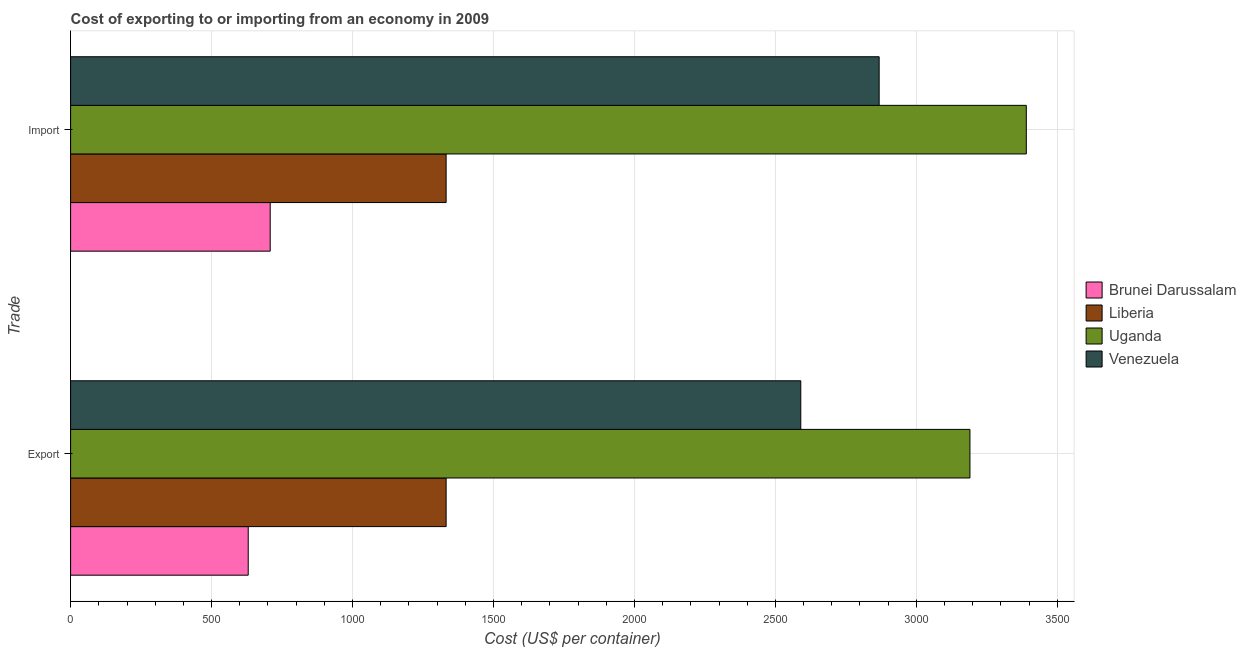How many different coloured bars are there?
Your answer should be compact. 4. How many bars are there on the 1st tick from the bottom?
Offer a very short reply. 4. What is the label of the 1st group of bars from the top?
Offer a very short reply. Import. What is the export cost in Brunei Darussalam?
Your response must be concise. 630. Across all countries, what is the maximum import cost?
Give a very brief answer. 3390. Across all countries, what is the minimum import cost?
Provide a succinct answer. 708. In which country was the export cost maximum?
Give a very brief answer. Uganda. In which country was the import cost minimum?
Provide a short and direct response. Brunei Darussalam. What is the total import cost in the graph?
Provide a succinct answer. 8298. What is the difference between the import cost in Venezuela and the export cost in Liberia?
Offer a terse response. 1536. What is the average import cost per country?
Offer a very short reply. 2074.5. What is the difference between the export cost and import cost in Brunei Darussalam?
Your answer should be compact. -78. In how many countries, is the import cost greater than 1100 US$?
Keep it short and to the point. 3. What is the ratio of the export cost in Brunei Darussalam to that in Venezuela?
Your answer should be very brief. 0.24. What does the 4th bar from the top in Import represents?
Your answer should be compact. Brunei Darussalam. What does the 1st bar from the bottom in Export represents?
Your response must be concise. Brunei Darussalam. How many countries are there in the graph?
Offer a terse response. 4. What is the difference between two consecutive major ticks on the X-axis?
Your answer should be very brief. 500. Are the values on the major ticks of X-axis written in scientific E-notation?
Make the answer very short. No. Does the graph contain any zero values?
Provide a succinct answer. No. Does the graph contain grids?
Your answer should be very brief. Yes. Where does the legend appear in the graph?
Provide a short and direct response. Center right. How many legend labels are there?
Ensure brevity in your answer.  4. What is the title of the graph?
Provide a succinct answer. Cost of exporting to or importing from an economy in 2009. What is the label or title of the X-axis?
Keep it short and to the point. Cost (US$ per container). What is the label or title of the Y-axis?
Your answer should be compact. Trade. What is the Cost (US$ per container) of Brunei Darussalam in Export?
Offer a terse response. 630. What is the Cost (US$ per container) in Liberia in Export?
Ensure brevity in your answer.  1332. What is the Cost (US$ per container) in Uganda in Export?
Make the answer very short. 3190. What is the Cost (US$ per container) in Venezuela in Export?
Your answer should be compact. 2590. What is the Cost (US$ per container) of Brunei Darussalam in Import?
Your answer should be compact. 708. What is the Cost (US$ per container) in Liberia in Import?
Your answer should be compact. 1332. What is the Cost (US$ per container) of Uganda in Import?
Your answer should be compact. 3390. What is the Cost (US$ per container) of Venezuela in Import?
Offer a very short reply. 2868. Across all Trade, what is the maximum Cost (US$ per container) of Brunei Darussalam?
Offer a very short reply. 708. Across all Trade, what is the maximum Cost (US$ per container) in Liberia?
Provide a succinct answer. 1332. Across all Trade, what is the maximum Cost (US$ per container) of Uganda?
Make the answer very short. 3390. Across all Trade, what is the maximum Cost (US$ per container) in Venezuela?
Provide a succinct answer. 2868. Across all Trade, what is the minimum Cost (US$ per container) in Brunei Darussalam?
Provide a succinct answer. 630. Across all Trade, what is the minimum Cost (US$ per container) of Liberia?
Make the answer very short. 1332. Across all Trade, what is the minimum Cost (US$ per container) of Uganda?
Provide a succinct answer. 3190. Across all Trade, what is the minimum Cost (US$ per container) of Venezuela?
Make the answer very short. 2590. What is the total Cost (US$ per container) in Brunei Darussalam in the graph?
Ensure brevity in your answer.  1338. What is the total Cost (US$ per container) in Liberia in the graph?
Offer a terse response. 2664. What is the total Cost (US$ per container) in Uganda in the graph?
Provide a succinct answer. 6580. What is the total Cost (US$ per container) in Venezuela in the graph?
Offer a very short reply. 5458. What is the difference between the Cost (US$ per container) in Brunei Darussalam in Export and that in Import?
Offer a terse response. -78. What is the difference between the Cost (US$ per container) in Uganda in Export and that in Import?
Make the answer very short. -200. What is the difference between the Cost (US$ per container) of Venezuela in Export and that in Import?
Provide a succinct answer. -278. What is the difference between the Cost (US$ per container) of Brunei Darussalam in Export and the Cost (US$ per container) of Liberia in Import?
Ensure brevity in your answer.  -702. What is the difference between the Cost (US$ per container) of Brunei Darussalam in Export and the Cost (US$ per container) of Uganda in Import?
Ensure brevity in your answer.  -2760. What is the difference between the Cost (US$ per container) in Brunei Darussalam in Export and the Cost (US$ per container) in Venezuela in Import?
Provide a succinct answer. -2238. What is the difference between the Cost (US$ per container) in Liberia in Export and the Cost (US$ per container) in Uganda in Import?
Provide a succinct answer. -2058. What is the difference between the Cost (US$ per container) of Liberia in Export and the Cost (US$ per container) of Venezuela in Import?
Your response must be concise. -1536. What is the difference between the Cost (US$ per container) of Uganda in Export and the Cost (US$ per container) of Venezuela in Import?
Provide a short and direct response. 322. What is the average Cost (US$ per container) of Brunei Darussalam per Trade?
Keep it short and to the point. 669. What is the average Cost (US$ per container) of Liberia per Trade?
Offer a very short reply. 1332. What is the average Cost (US$ per container) in Uganda per Trade?
Provide a short and direct response. 3290. What is the average Cost (US$ per container) in Venezuela per Trade?
Keep it short and to the point. 2729. What is the difference between the Cost (US$ per container) in Brunei Darussalam and Cost (US$ per container) in Liberia in Export?
Ensure brevity in your answer.  -702. What is the difference between the Cost (US$ per container) of Brunei Darussalam and Cost (US$ per container) of Uganda in Export?
Your response must be concise. -2560. What is the difference between the Cost (US$ per container) in Brunei Darussalam and Cost (US$ per container) in Venezuela in Export?
Your response must be concise. -1960. What is the difference between the Cost (US$ per container) of Liberia and Cost (US$ per container) of Uganda in Export?
Give a very brief answer. -1858. What is the difference between the Cost (US$ per container) of Liberia and Cost (US$ per container) of Venezuela in Export?
Provide a succinct answer. -1258. What is the difference between the Cost (US$ per container) in Uganda and Cost (US$ per container) in Venezuela in Export?
Keep it short and to the point. 600. What is the difference between the Cost (US$ per container) in Brunei Darussalam and Cost (US$ per container) in Liberia in Import?
Provide a short and direct response. -624. What is the difference between the Cost (US$ per container) of Brunei Darussalam and Cost (US$ per container) of Uganda in Import?
Your answer should be compact. -2682. What is the difference between the Cost (US$ per container) in Brunei Darussalam and Cost (US$ per container) in Venezuela in Import?
Make the answer very short. -2160. What is the difference between the Cost (US$ per container) in Liberia and Cost (US$ per container) in Uganda in Import?
Your answer should be very brief. -2058. What is the difference between the Cost (US$ per container) of Liberia and Cost (US$ per container) of Venezuela in Import?
Offer a terse response. -1536. What is the difference between the Cost (US$ per container) in Uganda and Cost (US$ per container) in Venezuela in Import?
Keep it short and to the point. 522. What is the ratio of the Cost (US$ per container) in Brunei Darussalam in Export to that in Import?
Your answer should be compact. 0.89. What is the ratio of the Cost (US$ per container) in Uganda in Export to that in Import?
Your answer should be very brief. 0.94. What is the ratio of the Cost (US$ per container) of Venezuela in Export to that in Import?
Offer a very short reply. 0.9. What is the difference between the highest and the second highest Cost (US$ per container) of Brunei Darussalam?
Ensure brevity in your answer.  78. What is the difference between the highest and the second highest Cost (US$ per container) of Venezuela?
Make the answer very short. 278. What is the difference between the highest and the lowest Cost (US$ per container) in Brunei Darussalam?
Ensure brevity in your answer.  78. What is the difference between the highest and the lowest Cost (US$ per container) in Liberia?
Your answer should be compact. 0. What is the difference between the highest and the lowest Cost (US$ per container) of Venezuela?
Give a very brief answer. 278. 